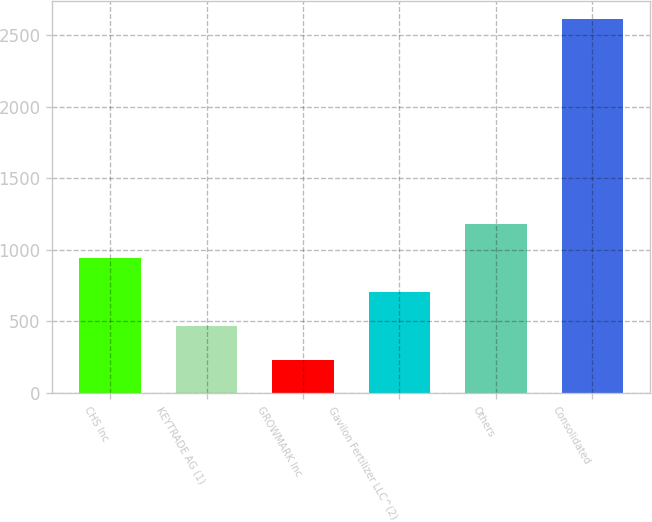Convert chart to OTSL. <chart><loc_0><loc_0><loc_500><loc_500><bar_chart><fcel>CHS Inc<fcel>KEYTRADE AG (1)<fcel>GROWMARK Inc<fcel>Gavilon Fertilizer LLC^(2)<fcel>Others<fcel>Consolidated<nl><fcel>946.18<fcel>471.26<fcel>233.8<fcel>708.72<fcel>1183.64<fcel>2608.4<nl></chart> 